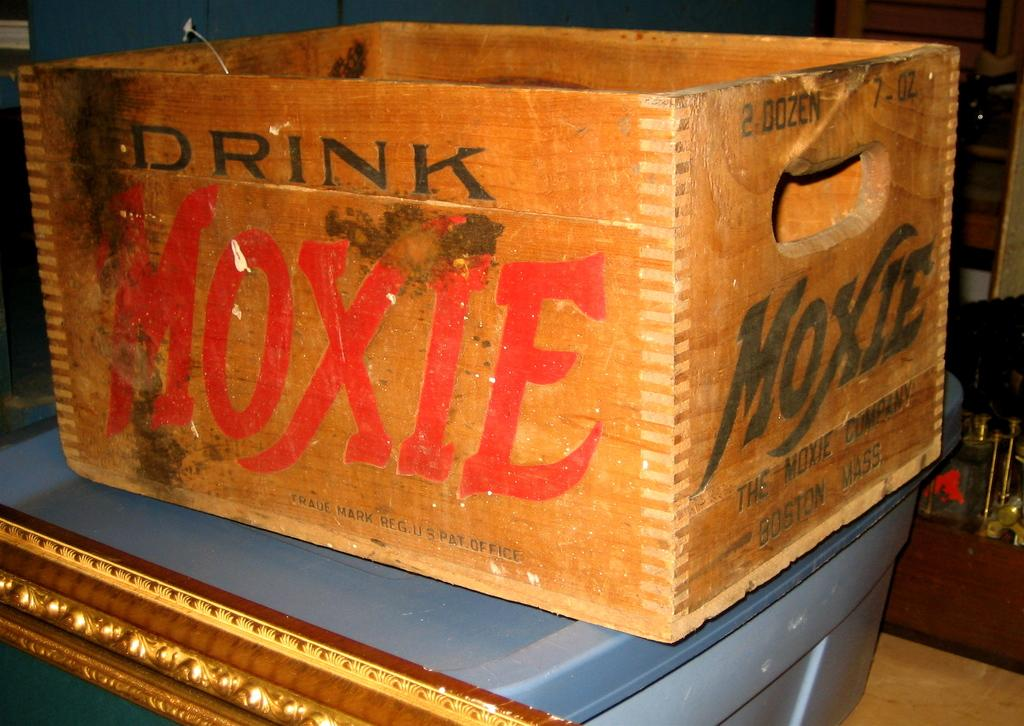Provide a one-sentence caption for the provided image. Drink Moxie is the slogan printed on the side of the crate. 